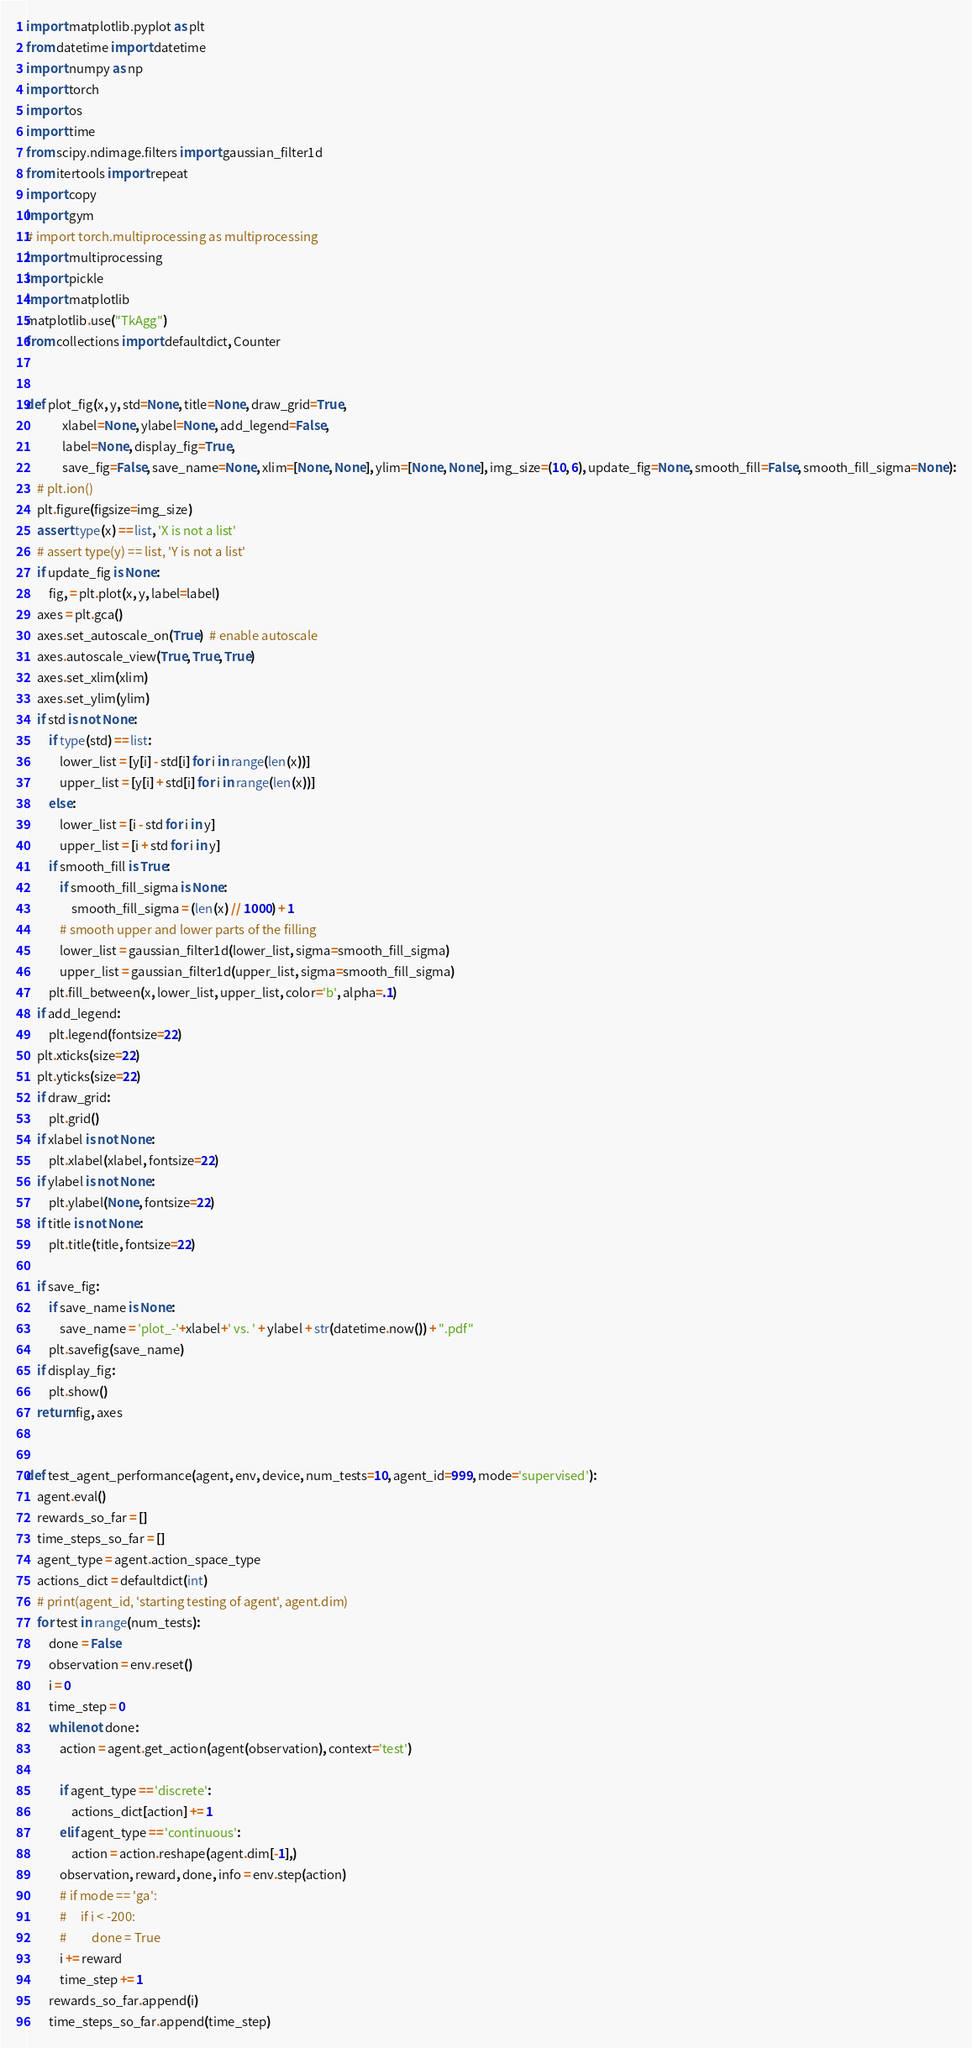<code> <loc_0><loc_0><loc_500><loc_500><_Python_>import matplotlib.pyplot as plt
from datetime import datetime
import numpy as np
import torch
import os
import time
from scipy.ndimage.filters import gaussian_filter1d
from itertools import repeat
import copy
import gym
# import torch.multiprocessing as multiprocessing
import multiprocessing
import pickle
import matplotlib
matplotlib.use("TkAgg")
from collections import defaultdict, Counter


def plot_fig(x, y, std=None, title=None, draw_grid=True,
             xlabel=None, ylabel=None, add_legend=False,
             label=None, display_fig=True,
             save_fig=False, save_name=None, xlim=[None, None], ylim=[None, None], img_size=(10, 6), update_fig=None, smooth_fill=False, smooth_fill_sigma=None):
    # plt.ion()
    plt.figure(figsize=img_size)
    assert type(x) == list, 'X is not a list'
    # assert type(y) == list, 'Y is not a list'
    if update_fig is None:
        fig, = plt.plot(x, y, label=label)
    axes = plt.gca()
    axes.set_autoscale_on(True)  # enable autoscale
    axes.autoscale_view(True, True, True)
    axes.set_xlim(xlim)
    axes.set_ylim(ylim)
    if std is not None:
        if type(std) == list:
            lower_list = [y[i] - std[i] for i in range(len(x))]
            upper_list = [y[i] + std[i] for i in range(len(x))]
        else:
            lower_list = [i - std for i in y]
            upper_list = [i + std for i in y]
        if smooth_fill is True:
            if smooth_fill_sigma is None:
                smooth_fill_sigma = (len(x) // 1000) + 1
            # smooth upper and lower parts of the filling
            lower_list = gaussian_filter1d(lower_list, sigma=smooth_fill_sigma)
            upper_list = gaussian_filter1d(upper_list, sigma=smooth_fill_sigma)
        plt.fill_between(x, lower_list, upper_list, color='b', alpha=.1)
    if add_legend:
        plt.legend(fontsize=22)
    plt.xticks(size=22)
    plt.yticks(size=22)
    if draw_grid:
        plt.grid()
    if xlabel is not None:
        plt.xlabel(xlabel, fontsize=22)
    if ylabel is not None:
        plt.ylabel(None, fontsize=22)
    if title is not None:
        plt.title(title, fontsize=22)

    if save_fig:
        if save_name is None:
            save_name = 'plot_-'+xlabel+' vs. ' + ylabel + str(datetime.now()) + ".pdf"
        plt.savefig(save_name)
    if display_fig:
        plt.show()
    return fig, axes


def test_agent_performance(agent, env, device, num_tests=10, agent_id=999, mode='supervised'):
    agent.eval()
    rewards_so_far = []
    time_steps_so_far = []
    agent_type = agent.action_space_type
    actions_dict = defaultdict(int)
    # print(agent_id, 'starting testing of agent', agent.dim)
    for test in range(num_tests):
        done = False
        observation = env.reset()
        i = 0
        time_step = 0
        while not done:
            action = agent.get_action(agent(observation), context='test')

            if agent_type == 'discrete':
                actions_dict[action] += 1
            elif agent_type == 'continuous':
                action = action.reshape(agent.dim[-1],)
            observation, reward, done, info = env.step(action)
            # if mode == 'ga':
            #     if i < -200:
            #         done = True
            i += reward
            time_step += 1
        rewards_so_far.append(i)
        time_steps_so_far.append(time_step)</code> 